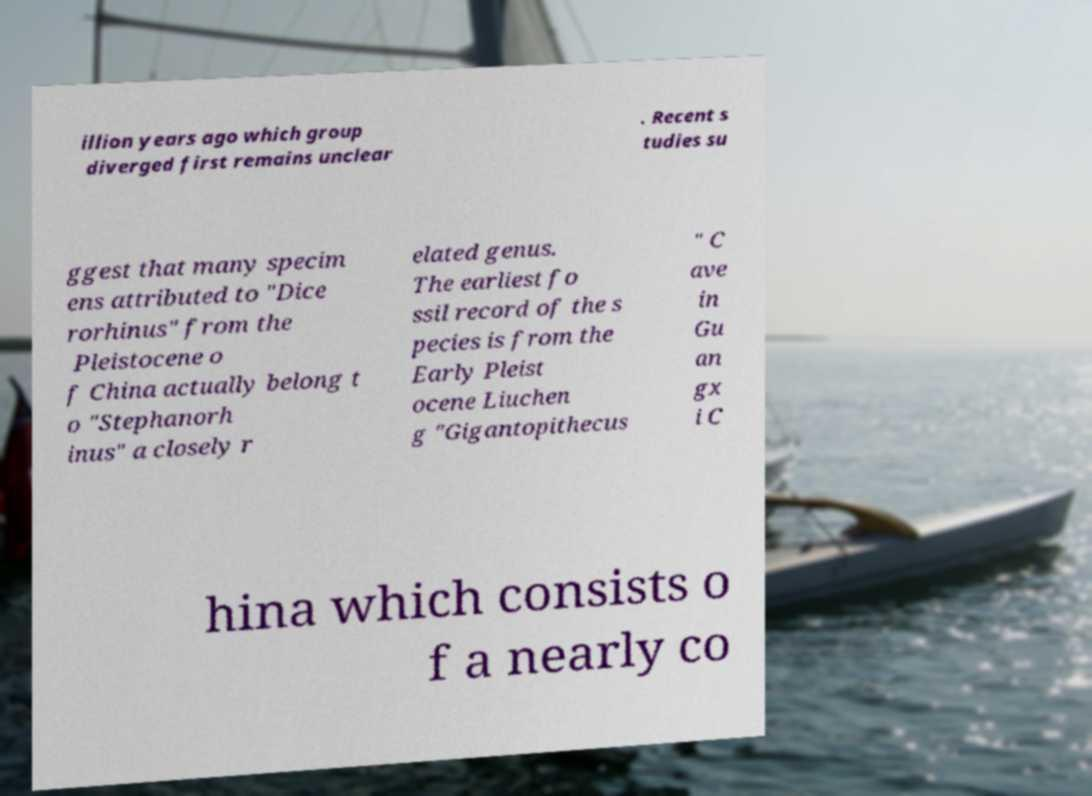Can you read and provide the text displayed in the image?This photo seems to have some interesting text. Can you extract and type it out for me? illion years ago which group diverged first remains unclear . Recent s tudies su ggest that many specim ens attributed to "Dice rorhinus" from the Pleistocene o f China actually belong t o "Stephanorh inus" a closely r elated genus. The earliest fo ssil record of the s pecies is from the Early Pleist ocene Liuchen g "Gigantopithecus " C ave in Gu an gx i C hina which consists o f a nearly co 